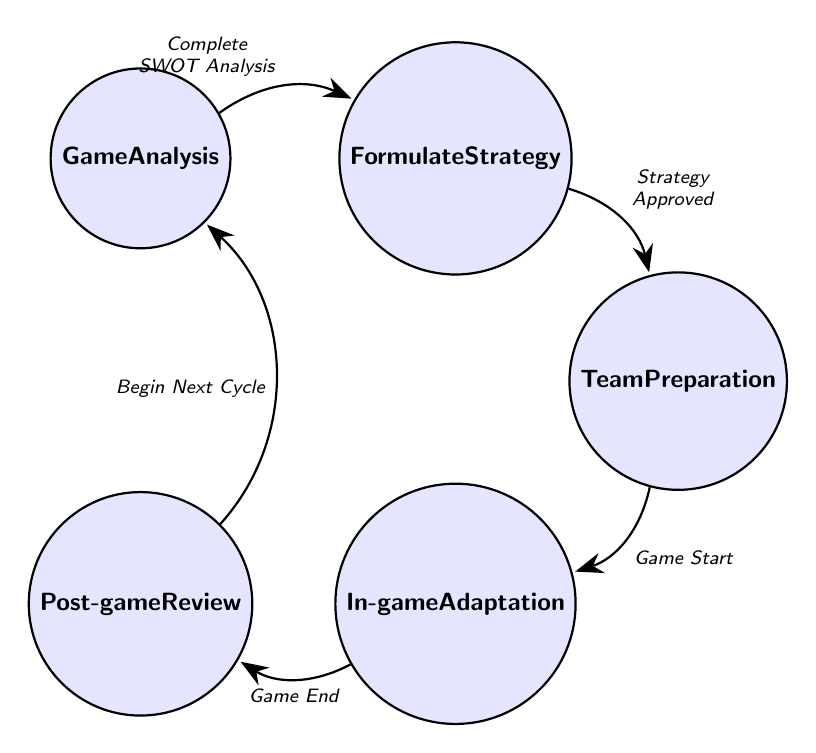What is the first state in the diagram? The first state, as indicated in the diagram, is "Game Analysis." It is the starting point from which the process initiates in the finite state machine.
Answer: Game Analysis How many states are there in total? The diagram contains five distinct states: Game Analysis, Formulate Strategy, Team Preparation, In-game Adaptation, and Post-game Review. Counting these gives a total of five states.
Answer: 5 Which state follows Team Preparation? The state that follows Team Preparation, as per the directed flow of transitions shown in the diagram, is "In-game Adaptation." This indicates the sequence in which the process progresses after Team Preparation.
Answer: In-game Adaptation What triggers the transition from In-game Adaptation to Post-game Review? The transition from In-game Adaptation to Post-game Review is triggered by the event "Game End." This represents the completion of the game and prompts the review stage.
Answer: Game End What is the trigger for the transition from Game Analysis to Formulate Strategy? The transition from Game Analysis to Formulate Strategy is triggered when the SWOT Analysis is completed. This means that the assessment of strengths, weaknesses, opportunities, and threats has been carried out successfully.
Answer: Complete SWOT Analysis Which state is entered after Post-game Review? After completing the Post-game Review, the next state to be entered is "Game Analysis" again, representing the cyclical nature of the process and the start of the next game preparation cycle.
Answer: Game Analysis What is the relationship between Formulate Strategy and Team Preparation? The relationship is that Team Preparation follows Formulate Strategy, triggered by the event "Strategy Approved." This indicates that the developed game plan has been accepted and the team is prepared accordingly.
Answer: Team Preparation Which state completes the finite state machine cycle? The state that completes the cycle of the finite state machine is "Post-game Review," as it leads back to "Game Analysis," showing that the process starts over after reviewing the previous game.
Answer: Post-game Review 